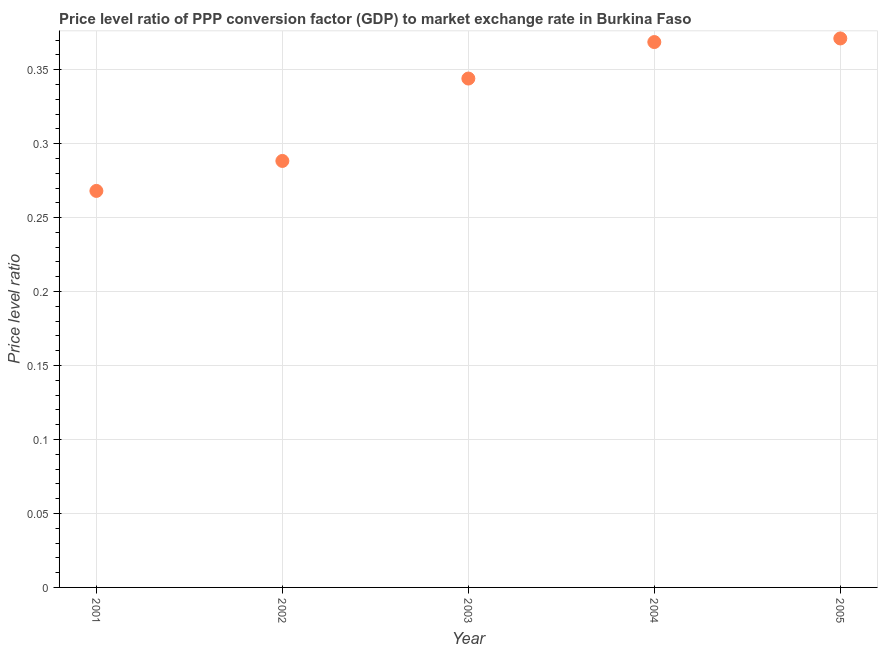What is the price level ratio in 2003?
Give a very brief answer. 0.34. Across all years, what is the maximum price level ratio?
Your answer should be very brief. 0.37. Across all years, what is the minimum price level ratio?
Offer a terse response. 0.27. In which year was the price level ratio minimum?
Your answer should be compact. 2001. What is the sum of the price level ratio?
Your answer should be compact. 1.64. What is the difference between the price level ratio in 2004 and 2005?
Give a very brief answer. -0. What is the average price level ratio per year?
Make the answer very short. 0.33. What is the median price level ratio?
Your answer should be very brief. 0.34. What is the ratio of the price level ratio in 2001 to that in 2003?
Make the answer very short. 0.78. Is the price level ratio in 2001 less than that in 2003?
Your answer should be compact. Yes. What is the difference between the highest and the second highest price level ratio?
Provide a succinct answer. 0. What is the difference between the highest and the lowest price level ratio?
Ensure brevity in your answer.  0.1. In how many years, is the price level ratio greater than the average price level ratio taken over all years?
Your answer should be very brief. 3. Does the price level ratio monotonically increase over the years?
Provide a short and direct response. Yes. How many dotlines are there?
Offer a terse response. 1. How many years are there in the graph?
Give a very brief answer. 5. What is the difference between two consecutive major ticks on the Y-axis?
Provide a succinct answer. 0.05. Does the graph contain grids?
Keep it short and to the point. Yes. What is the title of the graph?
Your answer should be compact. Price level ratio of PPP conversion factor (GDP) to market exchange rate in Burkina Faso. What is the label or title of the Y-axis?
Give a very brief answer. Price level ratio. What is the Price level ratio in 2001?
Offer a very short reply. 0.27. What is the Price level ratio in 2002?
Provide a short and direct response. 0.29. What is the Price level ratio in 2003?
Your answer should be compact. 0.34. What is the Price level ratio in 2004?
Your answer should be very brief. 0.37. What is the Price level ratio in 2005?
Give a very brief answer. 0.37. What is the difference between the Price level ratio in 2001 and 2002?
Give a very brief answer. -0.02. What is the difference between the Price level ratio in 2001 and 2003?
Ensure brevity in your answer.  -0.08. What is the difference between the Price level ratio in 2001 and 2004?
Give a very brief answer. -0.1. What is the difference between the Price level ratio in 2001 and 2005?
Give a very brief answer. -0.1. What is the difference between the Price level ratio in 2002 and 2003?
Offer a terse response. -0.06. What is the difference between the Price level ratio in 2002 and 2004?
Provide a succinct answer. -0.08. What is the difference between the Price level ratio in 2002 and 2005?
Your response must be concise. -0.08. What is the difference between the Price level ratio in 2003 and 2004?
Offer a very short reply. -0.02. What is the difference between the Price level ratio in 2003 and 2005?
Keep it short and to the point. -0.03. What is the difference between the Price level ratio in 2004 and 2005?
Your response must be concise. -0. What is the ratio of the Price level ratio in 2001 to that in 2003?
Offer a very short reply. 0.78. What is the ratio of the Price level ratio in 2001 to that in 2004?
Ensure brevity in your answer.  0.73. What is the ratio of the Price level ratio in 2001 to that in 2005?
Provide a succinct answer. 0.72. What is the ratio of the Price level ratio in 2002 to that in 2003?
Your response must be concise. 0.84. What is the ratio of the Price level ratio in 2002 to that in 2004?
Provide a succinct answer. 0.78. What is the ratio of the Price level ratio in 2002 to that in 2005?
Your response must be concise. 0.78. What is the ratio of the Price level ratio in 2003 to that in 2004?
Provide a succinct answer. 0.93. What is the ratio of the Price level ratio in 2003 to that in 2005?
Ensure brevity in your answer.  0.93. What is the ratio of the Price level ratio in 2004 to that in 2005?
Offer a terse response. 0.99. 